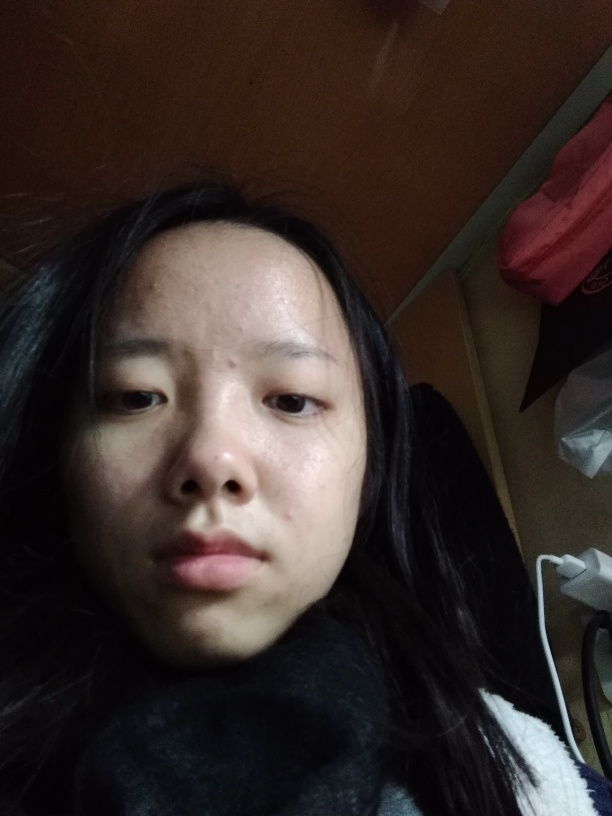What can you tell about the setting where this photo was taken? The image provides limited information about the setting, but we can infer that it's an indoor environment due to the presence of a wall and some household items in the background. The lighting and the casual attire of the subject suggest it's a personal space, possibly a room in a home. 